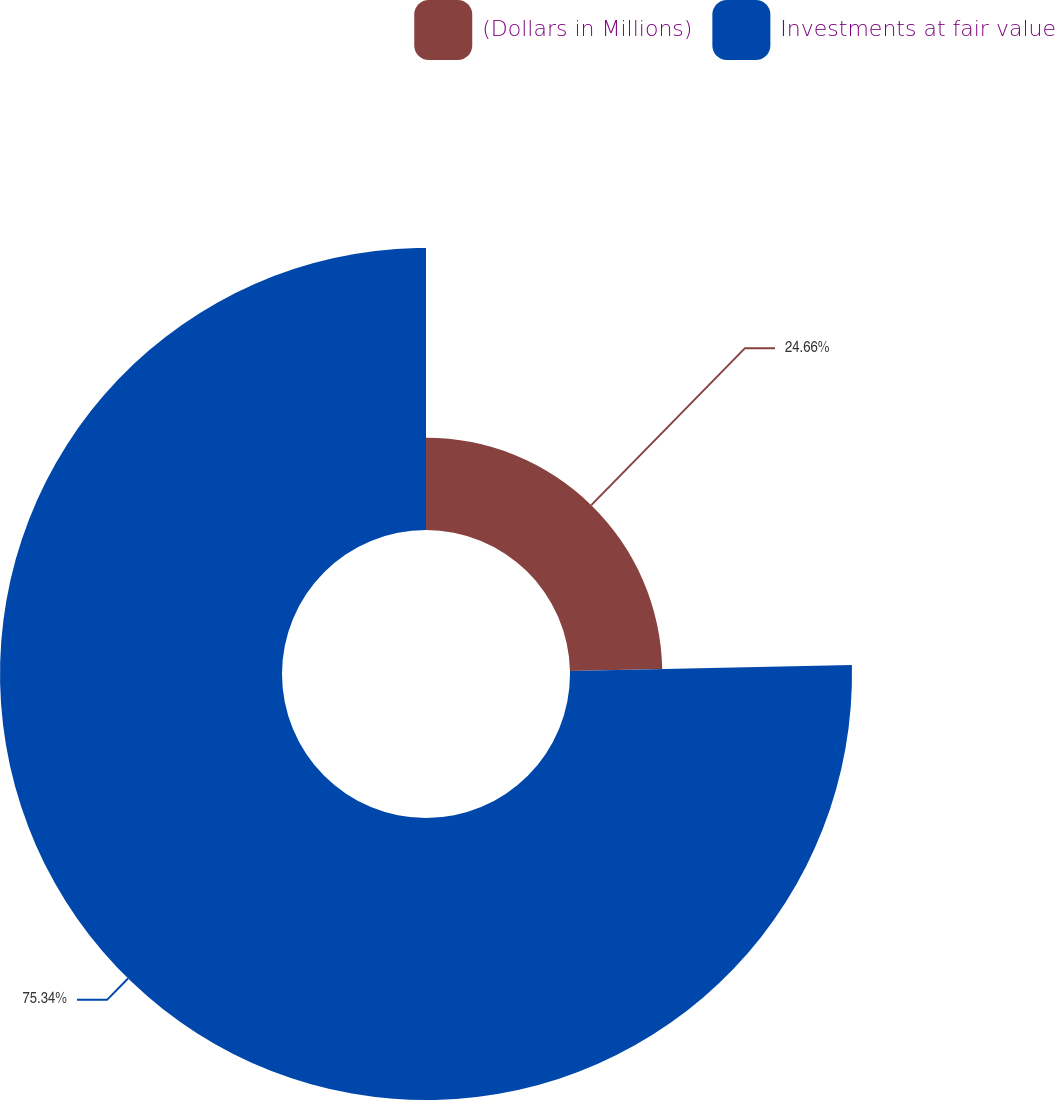Convert chart to OTSL. <chart><loc_0><loc_0><loc_500><loc_500><pie_chart><fcel>(Dollars in Millions)<fcel>Investments at fair value<nl><fcel>24.66%<fcel>75.34%<nl></chart> 